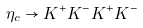Convert formula to latex. <formula><loc_0><loc_0><loc_500><loc_500>\eta _ { c } \rightarrow K ^ { + } K ^ { - } K ^ { + } K ^ { - }</formula> 